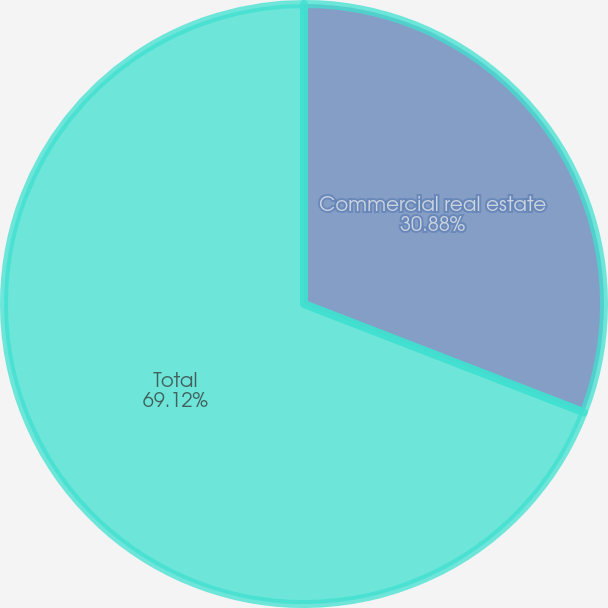Convert chart. <chart><loc_0><loc_0><loc_500><loc_500><pie_chart><fcel>Commercial real estate<fcel>Total<nl><fcel>30.88%<fcel>69.12%<nl></chart> 